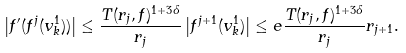<formula> <loc_0><loc_0><loc_500><loc_500>\left | f ^ { \prime } ( f ^ { j } ( v _ { k } ^ { 1 } ) ) \right | \leq \frac { T ( r _ { j } , f ) ^ { 1 + 3 \delta } } { r _ { j } } \left | f ^ { j + 1 } ( v _ { k } ^ { 1 } ) \right | \leq e \frac { T ( r _ { j } , f ) ^ { 1 + 3 \delta } } { r _ { j } } r _ { j + 1 } .</formula> 